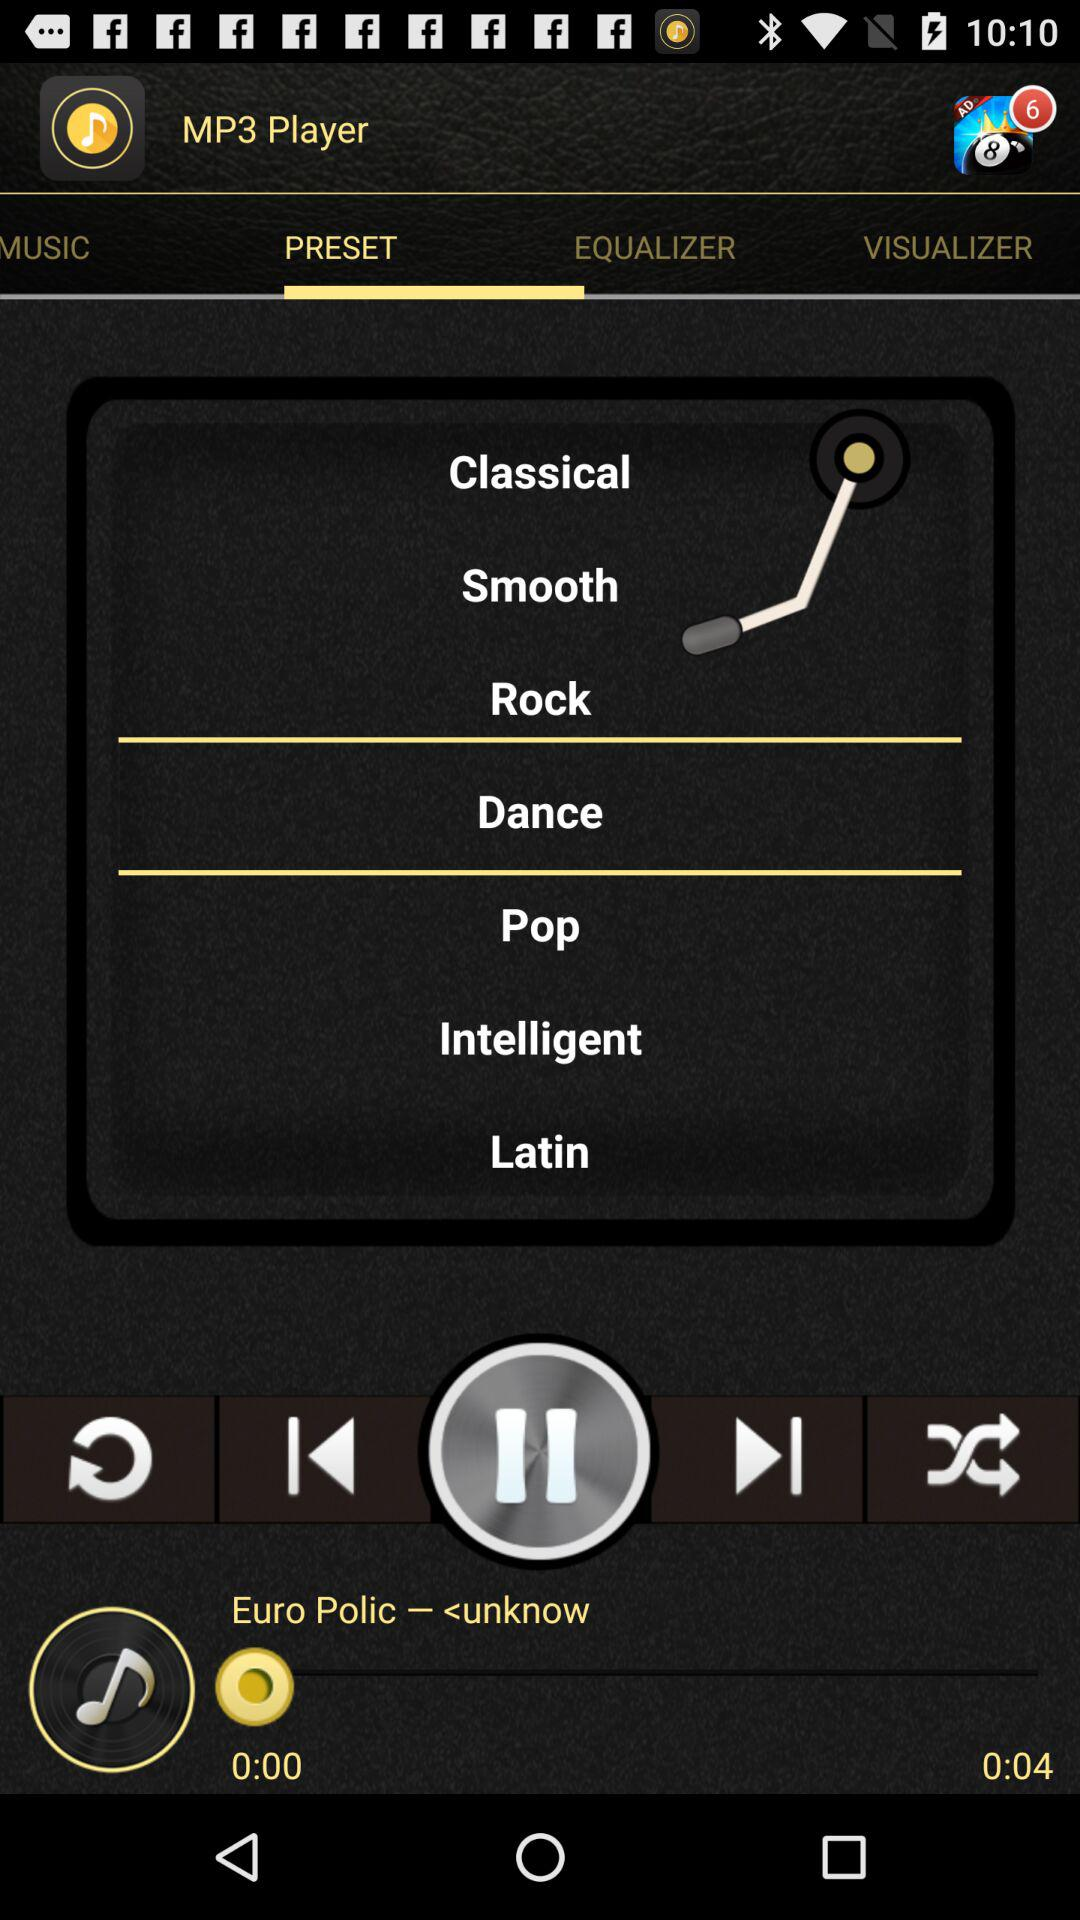Which tab is selected? The selected tab is "PRESET". 